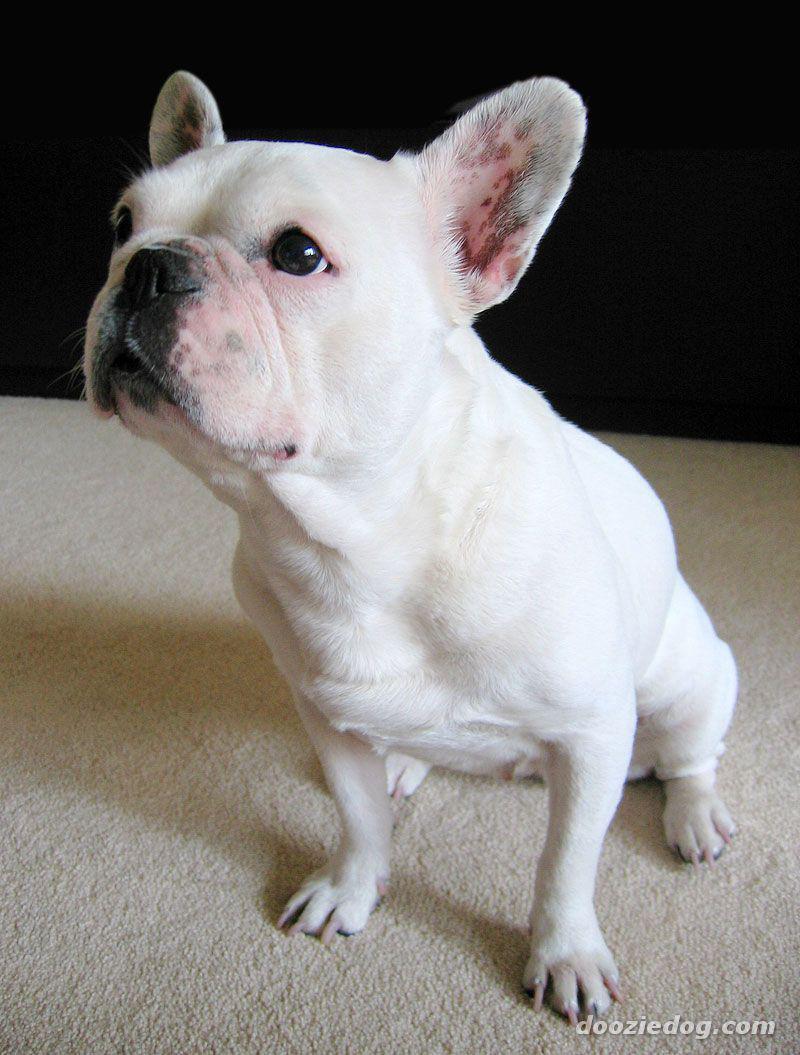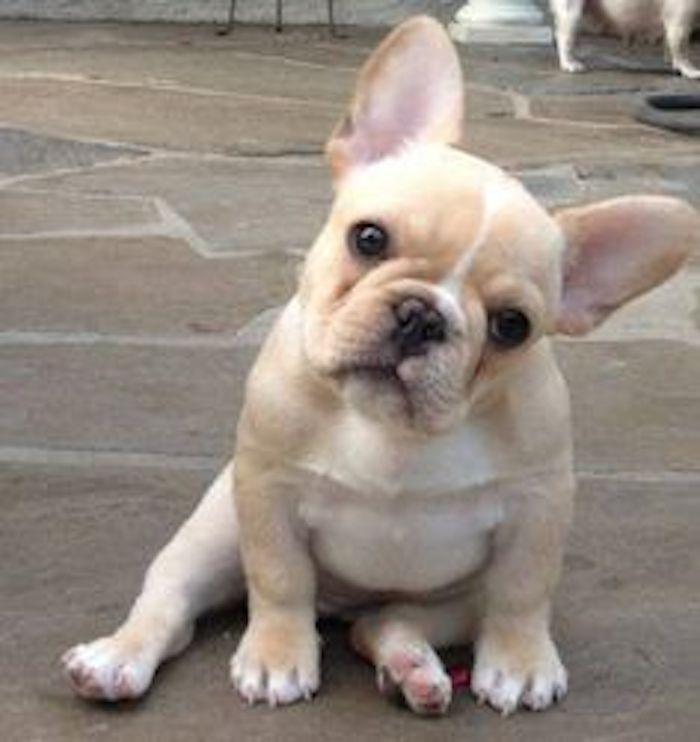The first image is the image on the left, the second image is the image on the right. For the images shown, is this caption "One dog is standing." true? Answer yes or no. No. The first image is the image on the left, the second image is the image on the right. For the images displayed, is the sentence "One image shows a french bulldog standing on all fours, and the other image includes a white bulldog looking straight at the camera." factually correct? Answer yes or no. No. 